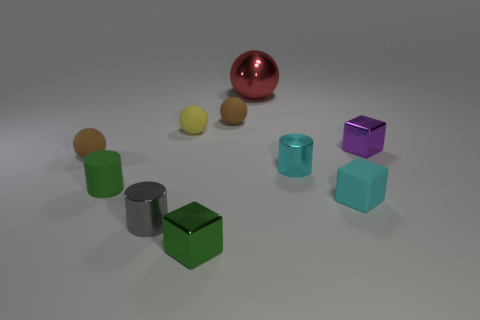Subtract 1 cylinders. How many cylinders are left? 2 Subtract all yellow spheres. How many spheres are left? 3 Subtract all red metallic balls. How many balls are left? 3 Subtract all purple spheres. Subtract all purple blocks. How many spheres are left? 4 Subtract all cylinders. How many objects are left? 7 Add 2 yellow rubber objects. How many yellow rubber objects are left? 3 Add 9 yellow rubber balls. How many yellow rubber balls exist? 10 Subtract 0 yellow cylinders. How many objects are left? 10 Subtract all green cubes. Subtract all tiny brown rubber objects. How many objects are left? 7 